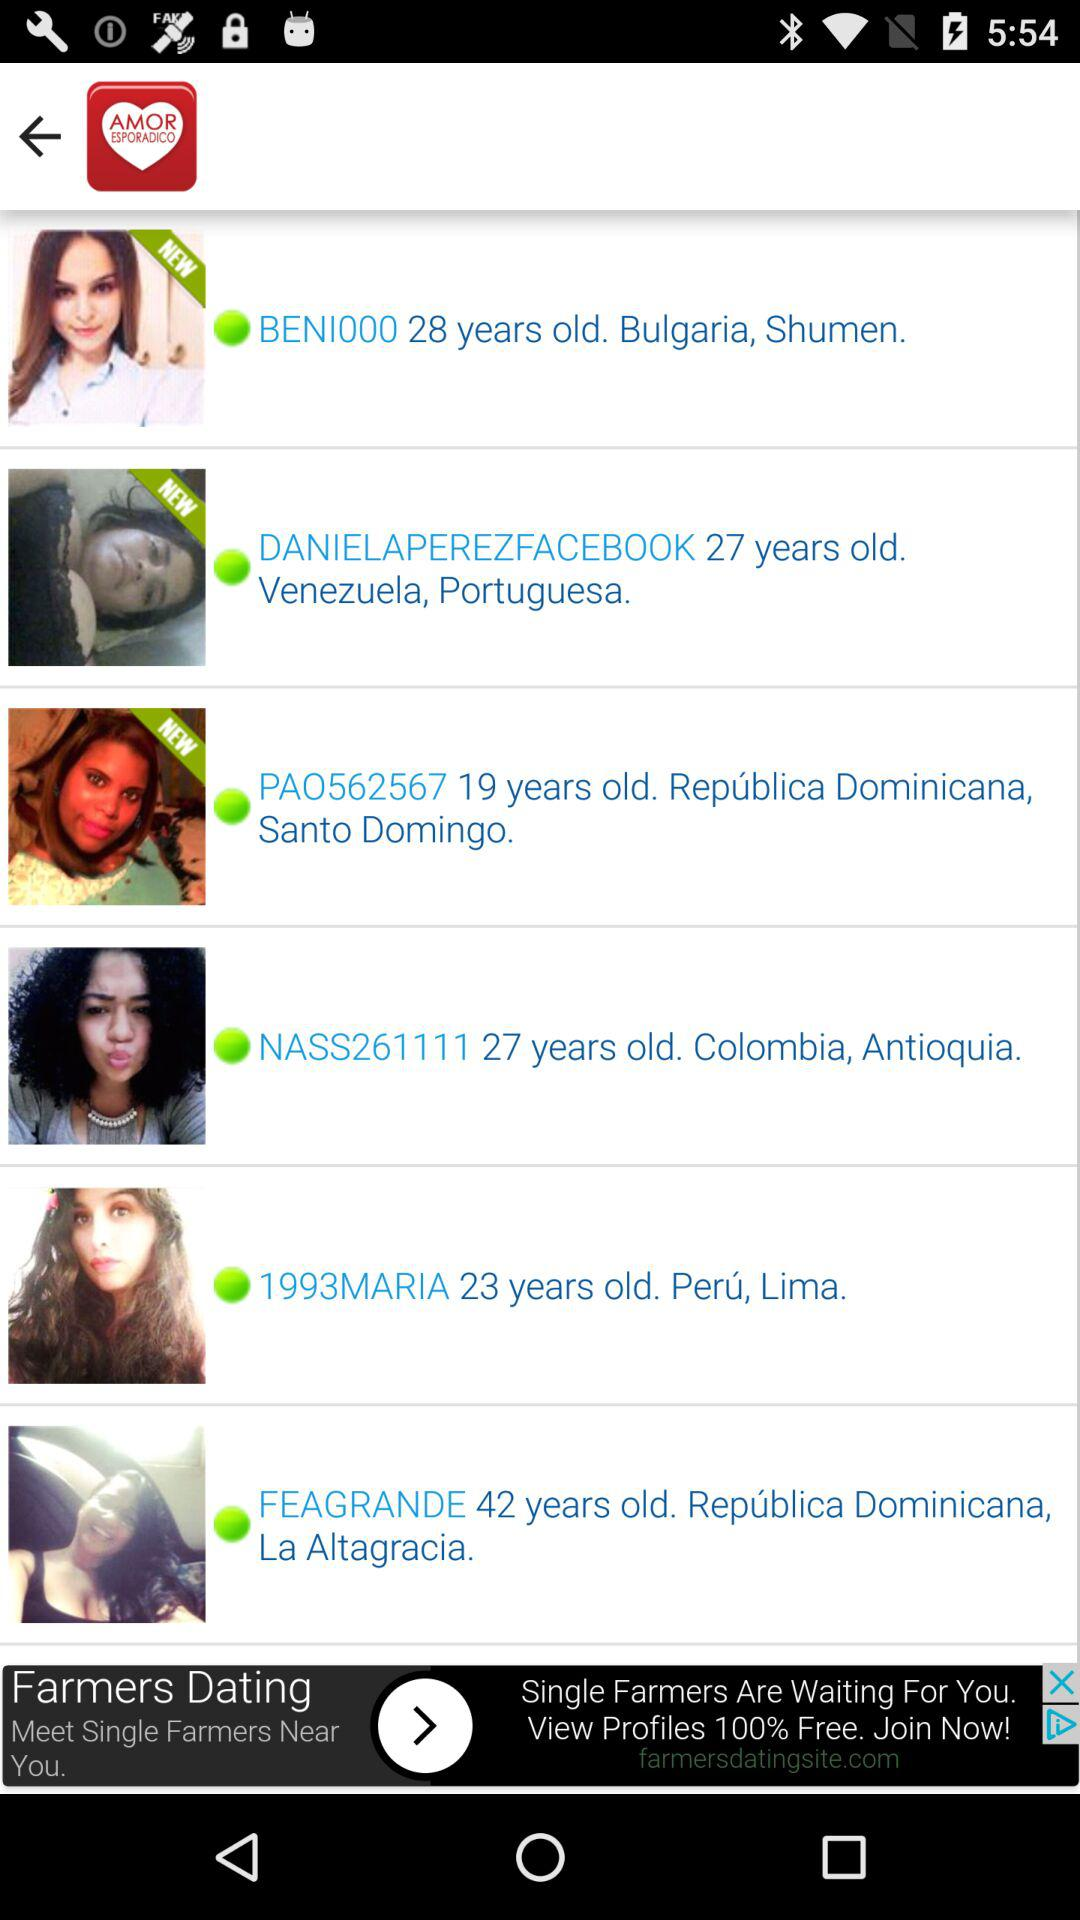What is the age of "1993MARIA"? The age of "1993MARIA" is 23 years. 